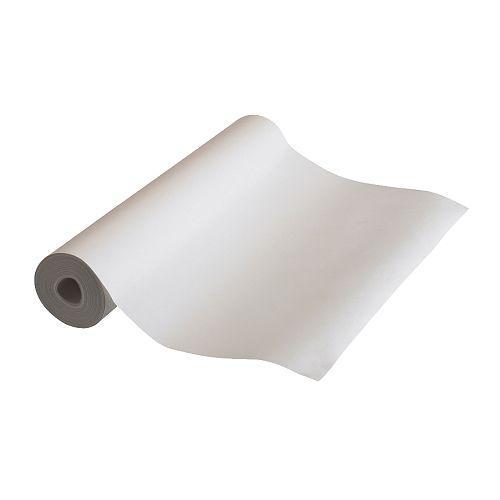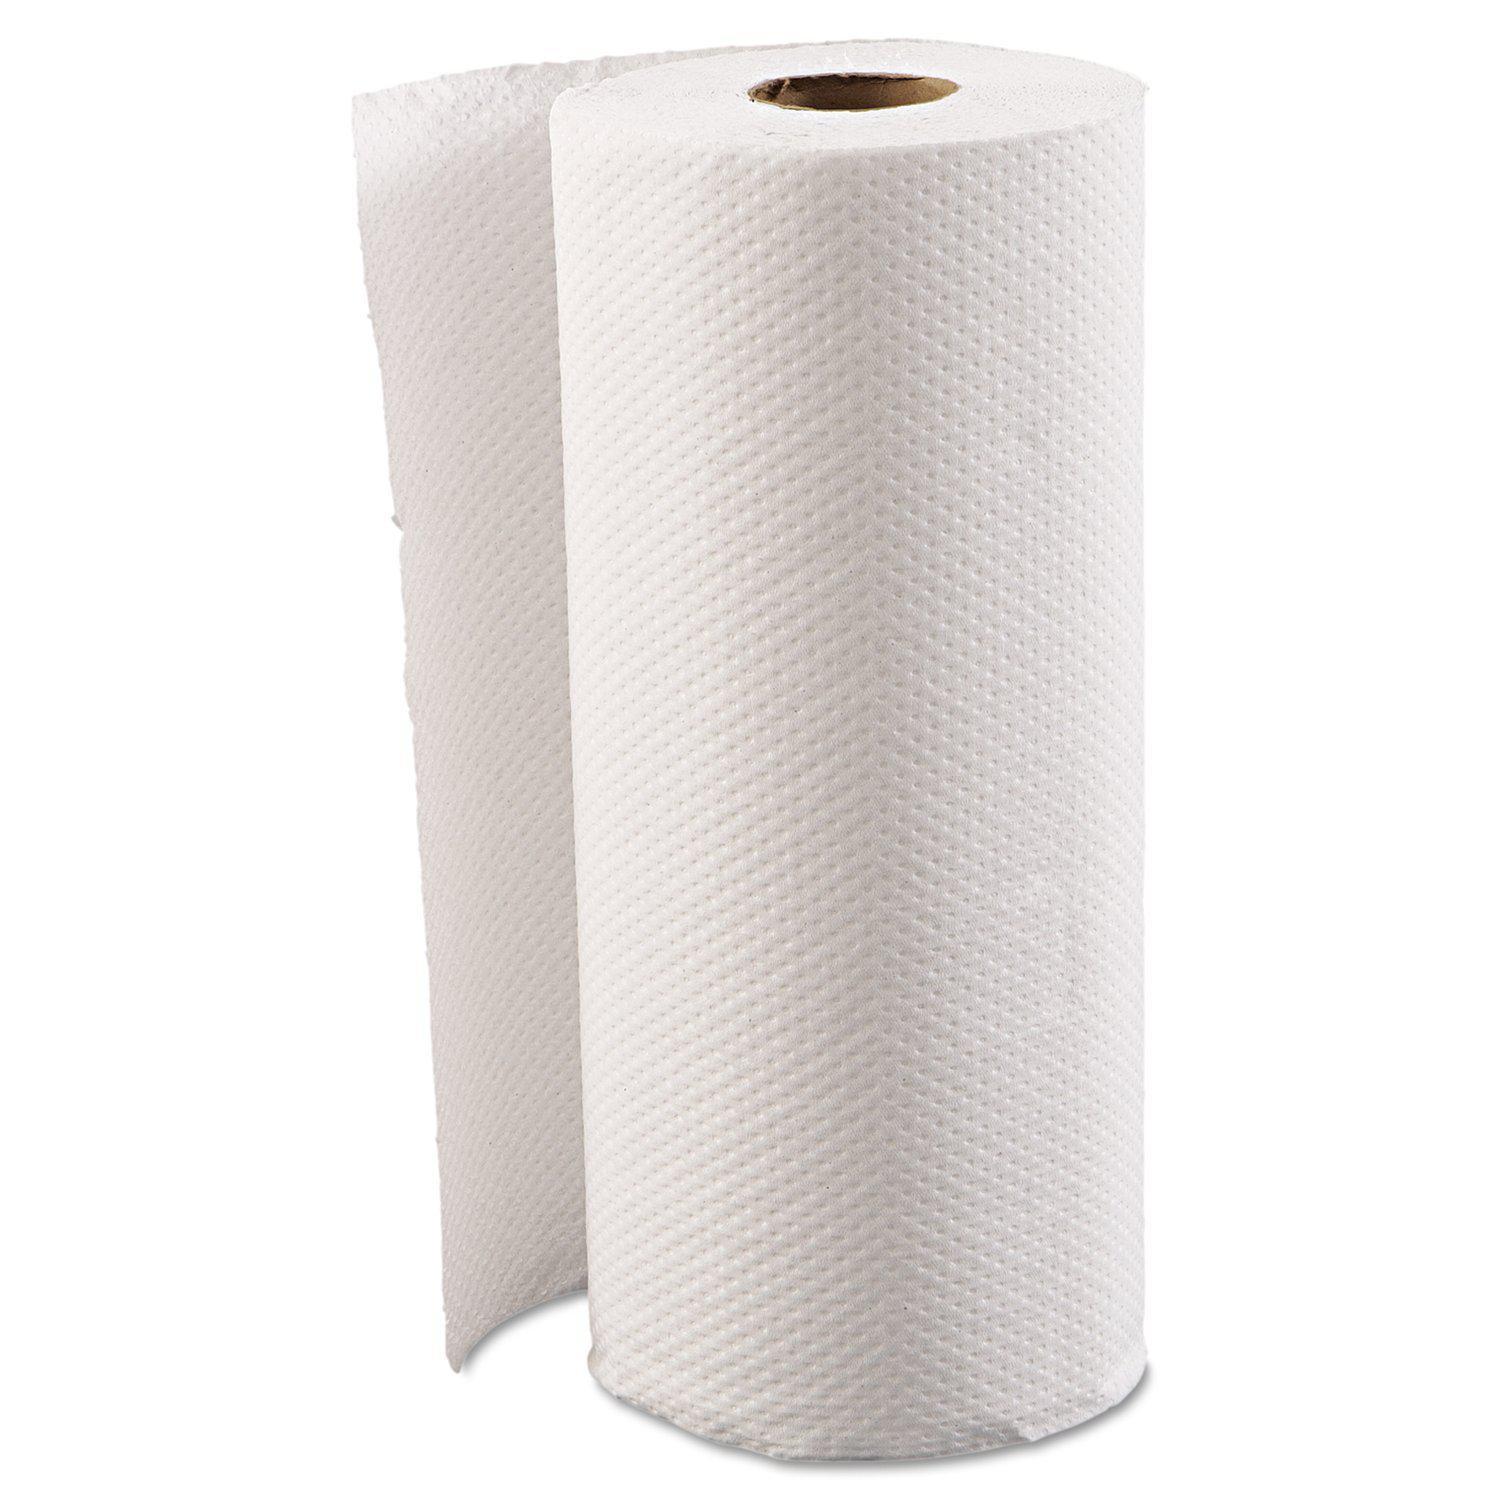The first image is the image on the left, the second image is the image on the right. For the images displayed, is the sentence "The left image contains at least five paper rolls." factually correct? Answer yes or no. No. 